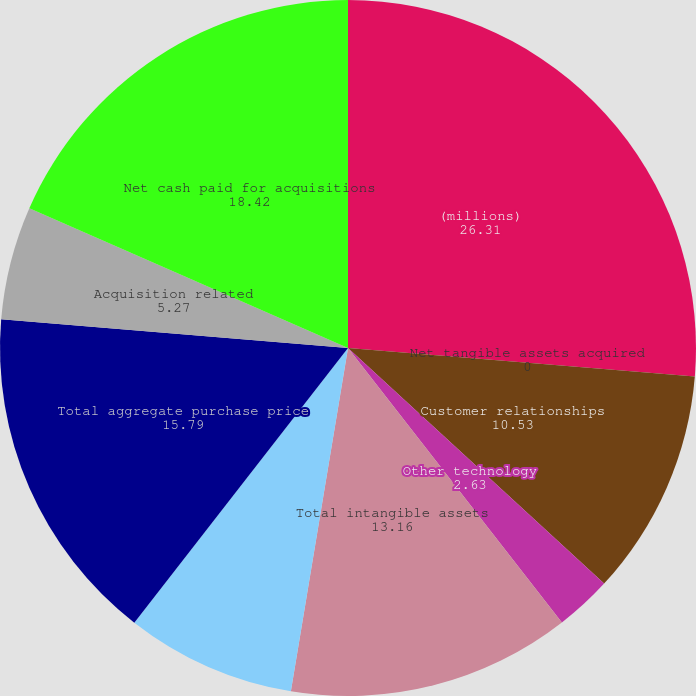Convert chart to OTSL. <chart><loc_0><loc_0><loc_500><loc_500><pie_chart><fcel>(millions)<fcel>Net tangible assets acquired<fcel>Customer relationships<fcel>Other technology<fcel>Total intangible assets<fcel>Goodwill<fcel>Total aggregate purchase price<fcel>Acquisition related<fcel>Net cash paid for acquisitions<nl><fcel>26.31%<fcel>0.0%<fcel>10.53%<fcel>2.63%<fcel>13.16%<fcel>7.9%<fcel>15.79%<fcel>5.27%<fcel>18.42%<nl></chart> 